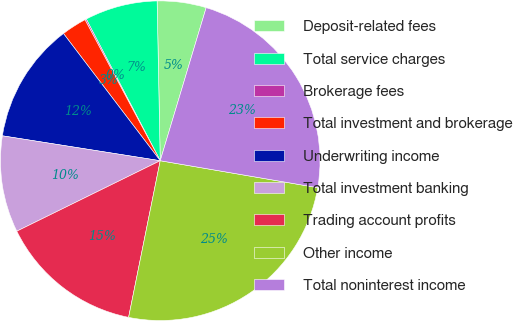Convert chart to OTSL. <chart><loc_0><loc_0><loc_500><loc_500><pie_chart><fcel>Deposit-related fees<fcel>Total service charges<fcel>Brokerage fees<fcel>Total investment and brokerage<fcel>Underwriting income<fcel>Total investment banking<fcel>Trading account profits<fcel>Other income<fcel>Total noninterest income<nl><fcel>4.95%<fcel>7.35%<fcel>0.14%<fcel>2.55%<fcel>12.16%<fcel>9.76%<fcel>14.56%<fcel>25.47%<fcel>23.06%<nl></chart> 